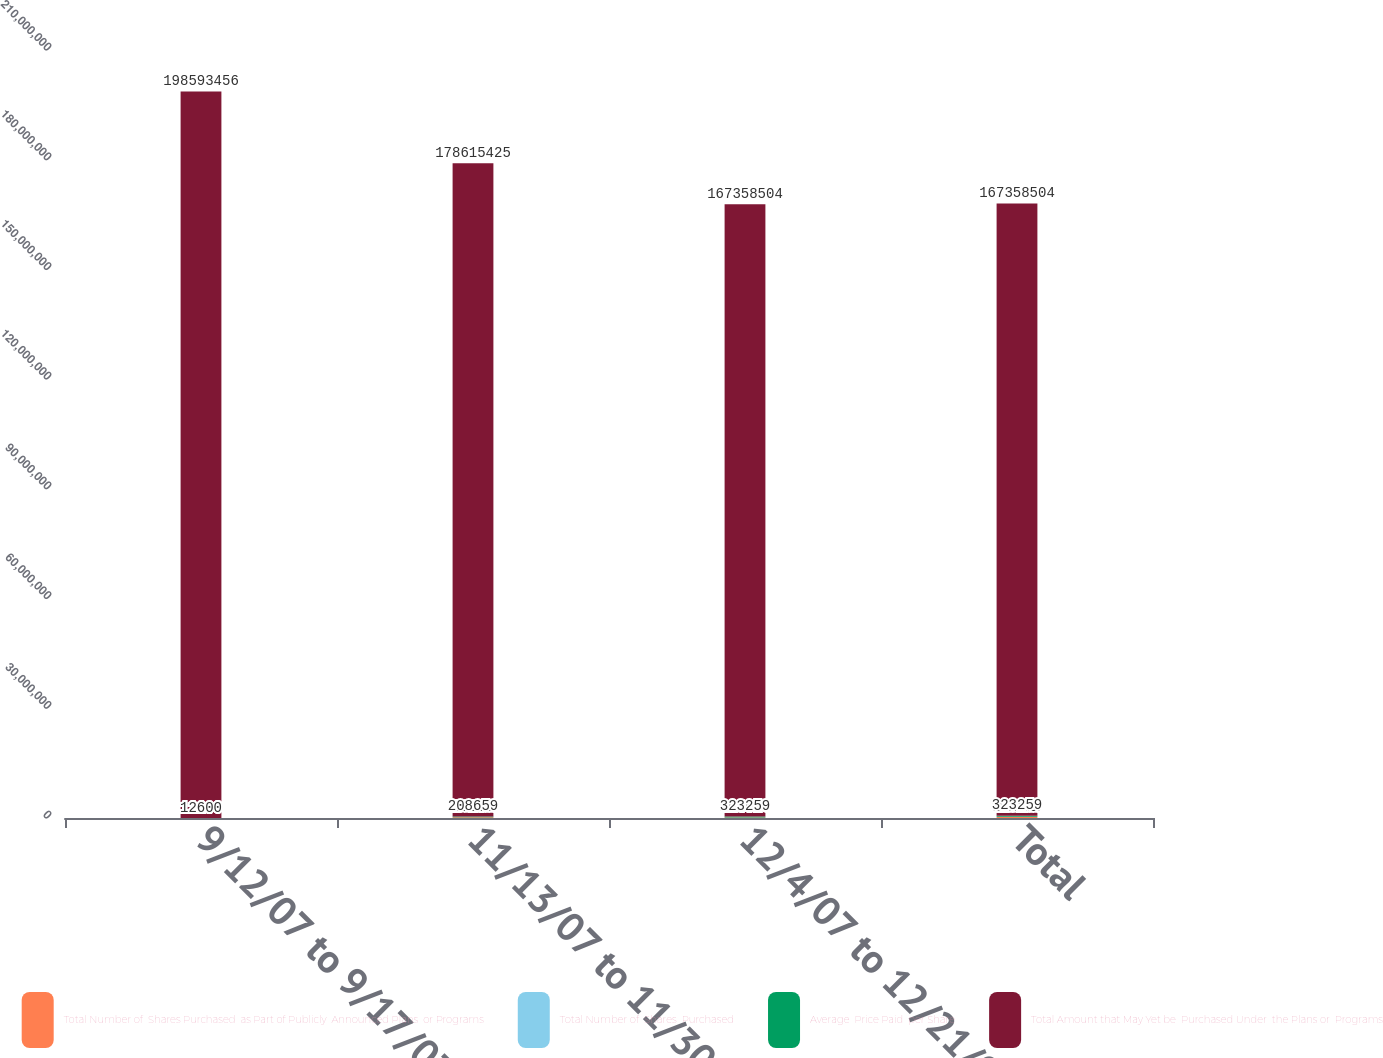Convert chart to OTSL. <chart><loc_0><loc_0><loc_500><loc_500><stacked_bar_chart><ecel><fcel>9/12/07 to 9/17/07<fcel>11/13/07 to 11/30/07<fcel>12/4/07 to 12/21/07<fcel>Total<nl><fcel>Total Number of  Shares Purchased  as Part of Publicly  Announced Plans  or Programs<fcel>12600<fcel>196059<fcel>114600<fcel>323259<nl><fcel>Total Number of  Shares  Purchased<fcel>111.6<fcel>101.9<fcel>98.2<fcel>100.9<nl><fcel>Average  Price Paid  per Share<fcel>12600<fcel>208659<fcel>323259<fcel>323259<nl><fcel>Total Amount that May Yet be  Purchased Under  the Plans or  Programs<fcel>1.98593e+08<fcel>1.78615e+08<fcel>1.67359e+08<fcel>1.67359e+08<nl></chart> 